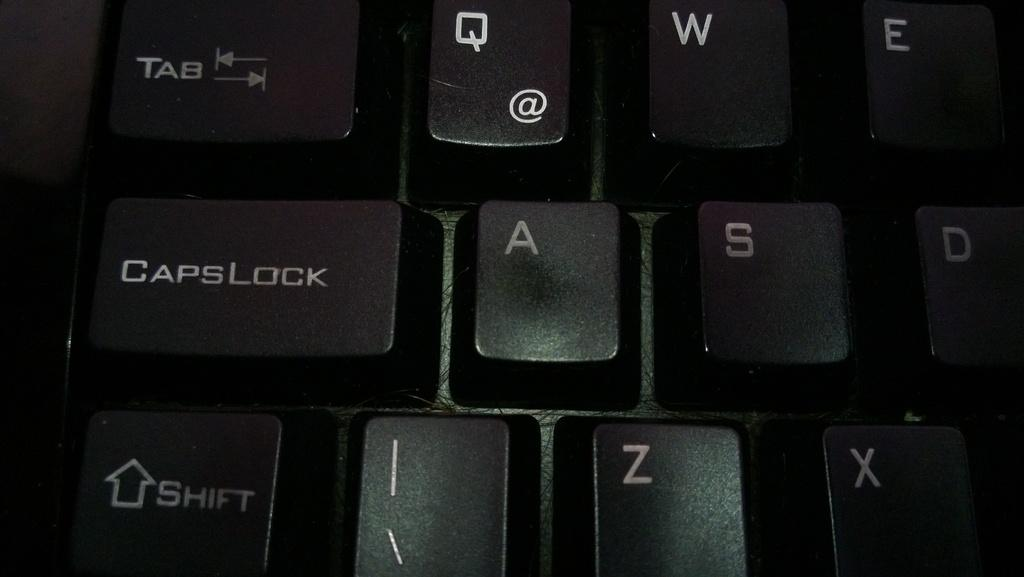<image>
Write a terse but informative summary of the picture. A black computer keyboard with the keys CapsLock and Shift shown 